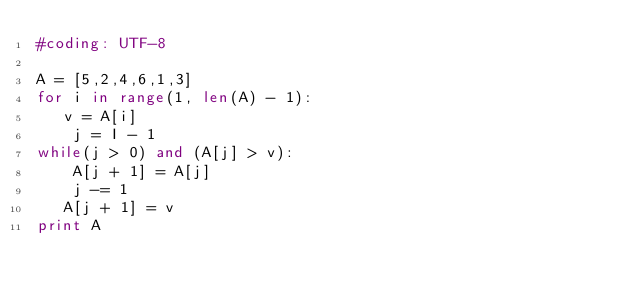Convert code to text. <code><loc_0><loc_0><loc_500><loc_500><_Python_>#coding: UTF-8

A = [5,2,4,6,1,3]
for i in range(1, len(A) - 1):
   v = A[i]
    j = I - 1
while(j > 0) and (A[j] > v):
    A[j + 1] = A[j]
    j -= 1
   A[j + 1] = v
print A</code> 